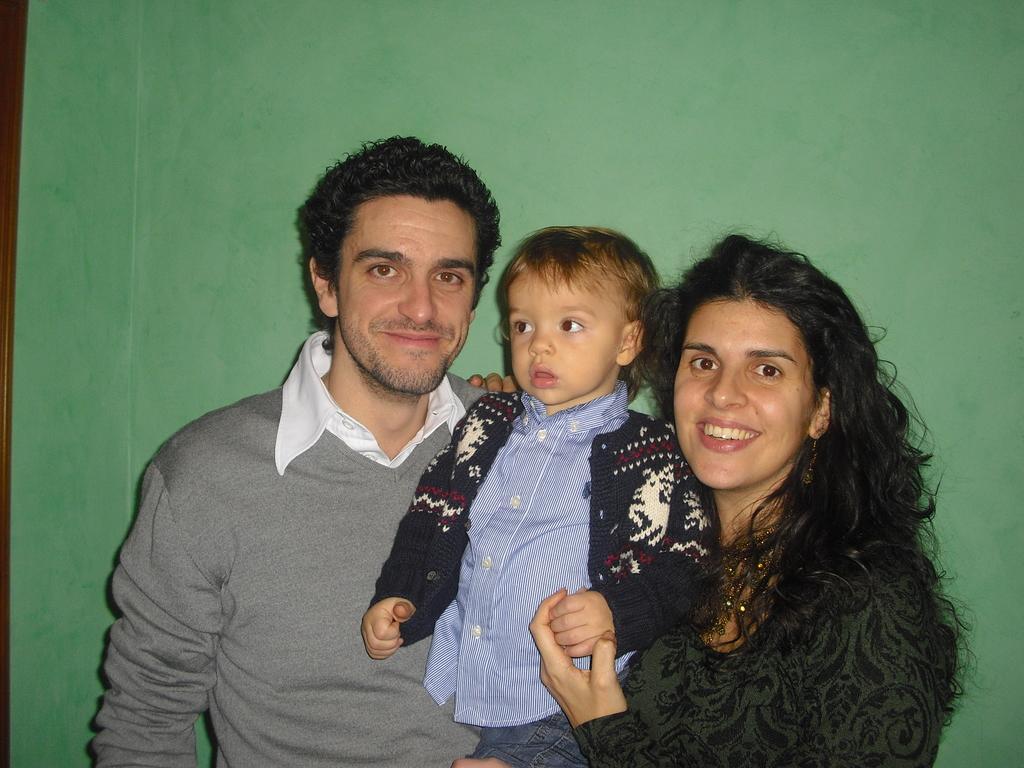Describe this image in one or two sentences. In this image I can see three people are wearing different color dresses. Background is in green color. 